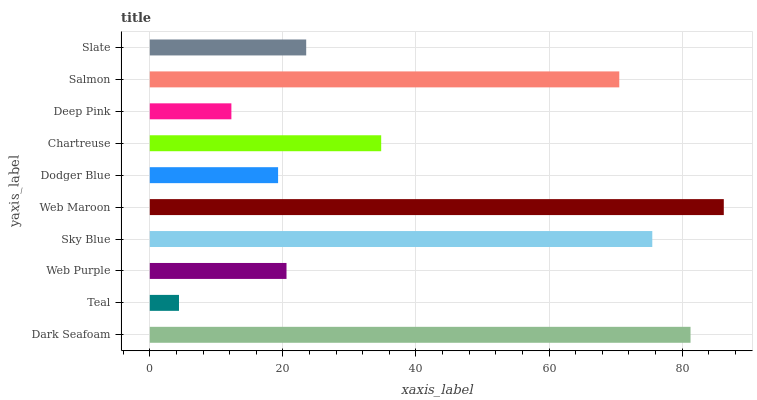Is Teal the minimum?
Answer yes or no. Yes. Is Web Maroon the maximum?
Answer yes or no. Yes. Is Web Purple the minimum?
Answer yes or no. No. Is Web Purple the maximum?
Answer yes or no. No. Is Web Purple greater than Teal?
Answer yes or no. Yes. Is Teal less than Web Purple?
Answer yes or no. Yes. Is Teal greater than Web Purple?
Answer yes or no. No. Is Web Purple less than Teal?
Answer yes or no. No. Is Chartreuse the high median?
Answer yes or no. Yes. Is Slate the low median?
Answer yes or no. Yes. Is Dodger Blue the high median?
Answer yes or no. No. Is Web Maroon the low median?
Answer yes or no. No. 